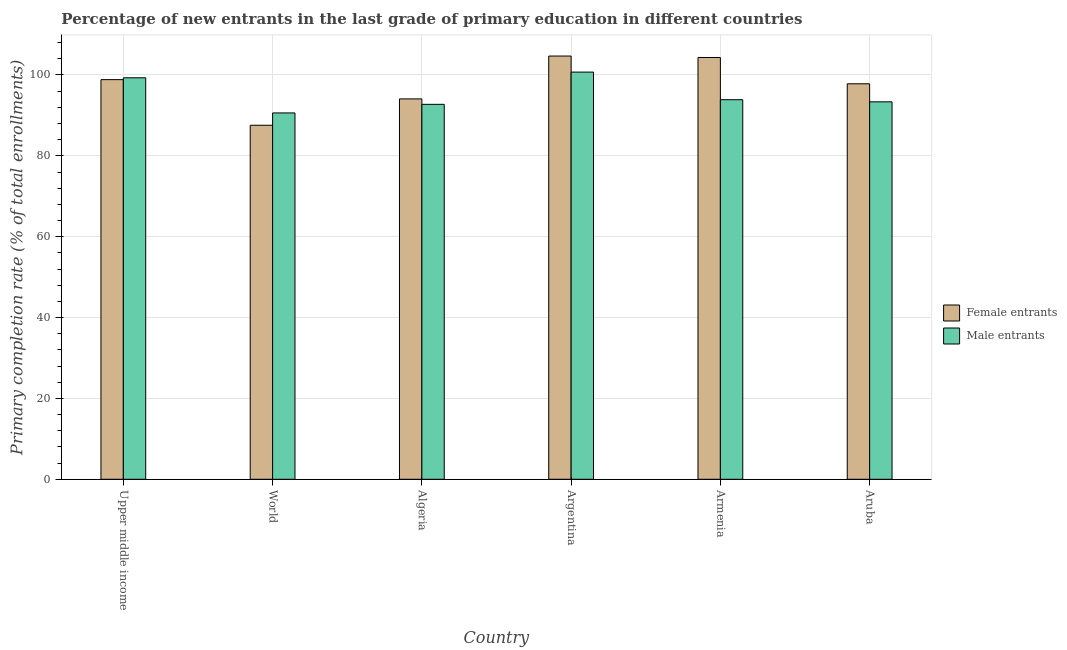How many different coloured bars are there?
Give a very brief answer. 2. How many groups of bars are there?
Give a very brief answer. 6. Are the number of bars per tick equal to the number of legend labels?
Provide a short and direct response. Yes. Are the number of bars on each tick of the X-axis equal?
Give a very brief answer. Yes. How many bars are there on the 2nd tick from the left?
Your response must be concise. 2. How many bars are there on the 3rd tick from the right?
Your answer should be very brief. 2. What is the label of the 6th group of bars from the left?
Your response must be concise. Aruba. What is the primary completion rate of male entrants in Algeria?
Provide a short and direct response. 92.74. Across all countries, what is the maximum primary completion rate of female entrants?
Offer a terse response. 104.69. Across all countries, what is the minimum primary completion rate of female entrants?
Make the answer very short. 87.57. In which country was the primary completion rate of female entrants maximum?
Make the answer very short. Argentina. In which country was the primary completion rate of male entrants minimum?
Your answer should be compact. World. What is the total primary completion rate of female entrants in the graph?
Your answer should be very brief. 587.34. What is the difference between the primary completion rate of female entrants in Argentina and that in Armenia?
Provide a short and direct response. 0.36. What is the difference between the primary completion rate of female entrants in Algeria and the primary completion rate of male entrants in Armenia?
Keep it short and to the point. 0.2. What is the average primary completion rate of male entrants per country?
Provide a succinct answer. 95.1. What is the difference between the primary completion rate of male entrants and primary completion rate of female entrants in Argentina?
Your answer should be compact. -3.97. What is the ratio of the primary completion rate of male entrants in Algeria to that in Armenia?
Offer a terse response. 0.99. Is the difference between the primary completion rate of female entrants in Armenia and Aruba greater than the difference between the primary completion rate of male entrants in Armenia and Aruba?
Your answer should be compact. Yes. What is the difference between the highest and the second highest primary completion rate of female entrants?
Your answer should be very brief. 0.36. What is the difference between the highest and the lowest primary completion rate of female entrants?
Your response must be concise. 17.12. In how many countries, is the primary completion rate of male entrants greater than the average primary completion rate of male entrants taken over all countries?
Offer a very short reply. 2. What does the 2nd bar from the left in World represents?
Your answer should be compact. Male entrants. What does the 2nd bar from the right in World represents?
Your answer should be compact. Female entrants. Are all the bars in the graph horizontal?
Your response must be concise. No. How many countries are there in the graph?
Offer a terse response. 6. What is the difference between two consecutive major ticks on the Y-axis?
Offer a terse response. 20. Where does the legend appear in the graph?
Your answer should be very brief. Center right. How are the legend labels stacked?
Keep it short and to the point. Vertical. What is the title of the graph?
Make the answer very short. Percentage of new entrants in the last grade of primary education in different countries. What is the label or title of the X-axis?
Keep it short and to the point. Country. What is the label or title of the Y-axis?
Offer a terse response. Primary completion rate (% of total enrollments). What is the Primary completion rate (% of total enrollments) in Female entrants in Upper middle income?
Give a very brief answer. 98.85. What is the Primary completion rate (% of total enrollments) of Male entrants in Upper middle income?
Your response must be concise. 99.31. What is the Primary completion rate (% of total enrollments) of Female entrants in World?
Offer a very short reply. 87.57. What is the Primary completion rate (% of total enrollments) in Male entrants in World?
Your answer should be very brief. 90.61. What is the Primary completion rate (% of total enrollments) in Female entrants in Algeria?
Your response must be concise. 94.09. What is the Primary completion rate (% of total enrollments) of Male entrants in Algeria?
Keep it short and to the point. 92.74. What is the Primary completion rate (% of total enrollments) in Female entrants in Argentina?
Your answer should be very brief. 104.69. What is the Primary completion rate (% of total enrollments) of Male entrants in Argentina?
Your response must be concise. 100.72. What is the Primary completion rate (% of total enrollments) of Female entrants in Armenia?
Offer a very short reply. 104.33. What is the Primary completion rate (% of total enrollments) of Male entrants in Armenia?
Offer a terse response. 93.88. What is the Primary completion rate (% of total enrollments) of Female entrants in Aruba?
Give a very brief answer. 97.82. What is the Primary completion rate (% of total enrollments) in Male entrants in Aruba?
Offer a terse response. 93.36. Across all countries, what is the maximum Primary completion rate (% of total enrollments) of Female entrants?
Your answer should be very brief. 104.69. Across all countries, what is the maximum Primary completion rate (% of total enrollments) of Male entrants?
Provide a succinct answer. 100.72. Across all countries, what is the minimum Primary completion rate (% of total enrollments) in Female entrants?
Provide a short and direct response. 87.57. Across all countries, what is the minimum Primary completion rate (% of total enrollments) of Male entrants?
Provide a succinct answer. 90.61. What is the total Primary completion rate (% of total enrollments) of Female entrants in the graph?
Keep it short and to the point. 587.34. What is the total Primary completion rate (% of total enrollments) of Male entrants in the graph?
Your answer should be compact. 570.63. What is the difference between the Primary completion rate (% of total enrollments) in Female entrants in Upper middle income and that in World?
Your answer should be very brief. 11.28. What is the difference between the Primary completion rate (% of total enrollments) of Male entrants in Upper middle income and that in World?
Offer a very short reply. 8.69. What is the difference between the Primary completion rate (% of total enrollments) in Female entrants in Upper middle income and that in Algeria?
Provide a short and direct response. 4.77. What is the difference between the Primary completion rate (% of total enrollments) in Male entrants in Upper middle income and that in Algeria?
Your answer should be compact. 6.57. What is the difference between the Primary completion rate (% of total enrollments) of Female entrants in Upper middle income and that in Argentina?
Offer a very short reply. -5.84. What is the difference between the Primary completion rate (% of total enrollments) of Male entrants in Upper middle income and that in Argentina?
Offer a terse response. -1.41. What is the difference between the Primary completion rate (% of total enrollments) of Female entrants in Upper middle income and that in Armenia?
Provide a succinct answer. -5.47. What is the difference between the Primary completion rate (% of total enrollments) in Male entrants in Upper middle income and that in Armenia?
Give a very brief answer. 5.43. What is the difference between the Primary completion rate (% of total enrollments) in Female entrants in Upper middle income and that in Aruba?
Your answer should be very brief. 1.03. What is the difference between the Primary completion rate (% of total enrollments) in Male entrants in Upper middle income and that in Aruba?
Keep it short and to the point. 5.95. What is the difference between the Primary completion rate (% of total enrollments) of Female entrants in World and that in Algeria?
Make the answer very short. -6.52. What is the difference between the Primary completion rate (% of total enrollments) in Male entrants in World and that in Algeria?
Keep it short and to the point. -2.13. What is the difference between the Primary completion rate (% of total enrollments) of Female entrants in World and that in Argentina?
Your response must be concise. -17.12. What is the difference between the Primary completion rate (% of total enrollments) of Male entrants in World and that in Argentina?
Make the answer very short. -10.1. What is the difference between the Primary completion rate (% of total enrollments) of Female entrants in World and that in Armenia?
Keep it short and to the point. -16.76. What is the difference between the Primary completion rate (% of total enrollments) of Male entrants in World and that in Armenia?
Your response must be concise. -3.27. What is the difference between the Primary completion rate (% of total enrollments) of Female entrants in World and that in Aruba?
Your answer should be very brief. -10.26. What is the difference between the Primary completion rate (% of total enrollments) of Male entrants in World and that in Aruba?
Your answer should be compact. -2.74. What is the difference between the Primary completion rate (% of total enrollments) in Female entrants in Algeria and that in Argentina?
Provide a succinct answer. -10.6. What is the difference between the Primary completion rate (% of total enrollments) in Male entrants in Algeria and that in Argentina?
Provide a short and direct response. -7.97. What is the difference between the Primary completion rate (% of total enrollments) in Female entrants in Algeria and that in Armenia?
Your answer should be compact. -10.24. What is the difference between the Primary completion rate (% of total enrollments) of Male entrants in Algeria and that in Armenia?
Offer a very short reply. -1.14. What is the difference between the Primary completion rate (% of total enrollments) in Female entrants in Algeria and that in Aruba?
Provide a succinct answer. -3.74. What is the difference between the Primary completion rate (% of total enrollments) in Male entrants in Algeria and that in Aruba?
Offer a terse response. -0.62. What is the difference between the Primary completion rate (% of total enrollments) of Female entrants in Argentina and that in Armenia?
Offer a very short reply. 0.36. What is the difference between the Primary completion rate (% of total enrollments) in Male entrants in Argentina and that in Armenia?
Ensure brevity in your answer.  6.83. What is the difference between the Primary completion rate (% of total enrollments) of Female entrants in Argentina and that in Aruba?
Your response must be concise. 6.87. What is the difference between the Primary completion rate (% of total enrollments) of Male entrants in Argentina and that in Aruba?
Ensure brevity in your answer.  7.36. What is the difference between the Primary completion rate (% of total enrollments) in Female entrants in Armenia and that in Aruba?
Make the answer very short. 6.5. What is the difference between the Primary completion rate (% of total enrollments) of Male entrants in Armenia and that in Aruba?
Your response must be concise. 0.53. What is the difference between the Primary completion rate (% of total enrollments) in Female entrants in Upper middle income and the Primary completion rate (% of total enrollments) in Male entrants in World?
Offer a terse response. 8.24. What is the difference between the Primary completion rate (% of total enrollments) in Female entrants in Upper middle income and the Primary completion rate (% of total enrollments) in Male entrants in Algeria?
Your response must be concise. 6.11. What is the difference between the Primary completion rate (% of total enrollments) in Female entrants in Upper middle income and the Primary completion rate (% of total enrollments) in Male entrants in Argentina?
Ensure brevity in your answer.  -1.87. What is the difference between the Primary completion rate (% of total enrollments) of Female entrants in Upper middle income and the Primary completion rate (% of total enrollments) of Male entrants in Armenia?
Your response must be concise. 4.97. What is the difference between the Primary completion rate (% of total enrollments) of Female entrants in Upper middle income and the Primary completion rate (% of total enrollments) of Male entrants in Aruba?
Give a very brief answer. 5.49. What is the difference between the Primary completion rate (% of total enrollments) of Female entrants in World and the Primary completion rate (% of total enrollments) of Male entrants in Algeria?
Give a very brief answer. -5.18. What is the difference between the Primary completion rate (% of total enrollments) of Female entrants in World and the Primary completion rate (% of total enrollments) of Male entrants in Argentina?
Offer a very short reply. -13.15. What is the difference between the Primary completion rate (% of total enrollments) in Female entrants in World and the Primary completion rate (% of total enrollments) in Male entrants in Armenia?
Provide a short and direct response. -6.32. What is the difference between the Primary completion rate (% of total enrollments) of Female entrants in World and the Primary completion rate (% of total enrollments) of Male entrants in Aruba?
Provide a short and direct response. -5.79. What is the difference between the Primary completion rate (% of total enrollments) in Female entrants in Algeria and the Primary completion rate (% of total enrollments) in Male entrants in Argentina?
Provide a short and direct response. -6.63. What is the difference between the Primary completion rate (% of total enrollments) in Female entrants in Algeria and the Primary completion rate (% of total enrollments) in Male entrants in Armenia?
Provide a succinct answer. 0.2. What is the difference between the Primary completion rate (% of total enrollments) of Female entrants in Algeria and the Primary completion rate (% of total enrollments) of Male entrants in Aruba?
Offer a terse response. 0.73. What is the difference between the Primary completion rate (% of total enrollments) in Female entrants in Argentina and the Primary completion rate (% of total enrollments) in Male entrants in Armenia?
Keep it short and to the point. 10.8. What is the difference between the Primary completion rate (% of total enrollments) in Female entrants in Argentina and the Primary completion rate (% of total enrollments) in Male entrants in Aruba?
Make the answer very short. 11.33. What is the difference between the Primary completion rate (% of total enrollments) in Female entrants in Armenia and the Primary completion rate (% of total enrollments) in Male entrants in Aruba?
Provide a succinct answer. 10.97. What is the average Primary completion rate (% of total enrollments) of Female entrants per country?
Offer a terse response. 97.89. What is the average Primary completion rate (% of total enrollments) of Male entrants per country?
Your response must be concise. 95.1. What is the difference between the Primary completion rate (% of total enrollments) of Female entrants and Primary completion rate (% of total enrollments) of Male entrants in Upper middle income?
Your answer should be compact. -0.46. What is the difference between the Primary completion rate (% of total enrollments) in Female entrants and Primary completion rate (% of total enrollments) in Male entrants in World?
Give a very brief answer. -3.05. What is the difference between the Primary completion rate (% of total enrollments) of Female entrants and Primary completion rate (% of total enrollments) of Male entrants in Algeria?
Provide a succinct answer. 1.34. What is the difference between the Primary completion rate (% of total enrollments) in Female entrants and Primary completion rate (% of total enrollments) in Male entrants in Argentina?
Ensure brevity in your answer.  3.97. What is the difference between the Primary completion rate (% of total enrollments) in Female entrants and Primary completion rate (% of total enrollments) in Male entrants in Armenia?
Provide a succinct answer. 10.44. What is the difference between the Primary completion rate (% of total enrollments) in Female entrants and Primary completion rate (% of total enrollments) in Male entrants in Aruba?
Your answer should be very brief. 4.46. What is the ratio of the Primary completion rate (% of total enrollments) in Female entrants in Upper middle income to that in World?
Your response must be concise. 1.13. What is the ratio of the Primary completion rate (% of total enrollments) in Male entrants in Upper middle income to that in World?
Keep it short and to the point. 1.1. What is the ratio of the Primary completion rate (% of total enrollments) in Female entrants in Upper middle income to that in Algeria?
Make the answer very short. 1.05. What is the ratio of the Primary completion rate (% of total enrollments) of Male entrants in Upper middle income to that in Algeria?
Your answer should be very brief. 1.07. What is the ratio of the Primary completion rate (% of total enrollments) of Female entrants in Upper middle income to that in Argentina?
Ensure brevity in your answer.  0.94. What is the ratio of the Primary completion rate (% of total enrollments) in Female entrants in Upper middle income to that in Armenia?
Provide a short and direct response. 0.95. What is the ratio of the Primary completion rate (% of total enrollments) in Male entrants in Upper middle income to that in Armenia?
Make the answer very short. 1.06. What is the ratio of the Primary completion rate (% of total enrollments) in Female entrants in Upper middle income to that in Aruba?
Ensure brevity in your answer.  1.01. What is the ratio of the Primary completion rate (% of total enrollments) of Male entrants in Upper middle income to that in Aruba?
Your answer should be very brief. 1.06. What is the ratio of the Primary completion rate (% of total enrollments) in Female entrants in World to that in Algeria?
Keep it short and to the point. 0.93. What is the ratio of the Primary completion rate (% of total enrollments) of Male entrants in World to that in Algeria?
Provide a short and direct response. 0.98. What is the ratio of the Primary completion rate (% of total enrollments) in Female entrants in World to that in Argentina?
Provide a short and direct response. 0.84. What is the ratio of the Primary completion rate (% of total enrollments) in Male entrants in World to that in Argentina?
Provide a short and direct response. 0.9. What is the ratio of the Primary completion rate (% of total enrollments) in Female entrants in World to that in Armenia?
Offer a very short reply. 0.84. What is the ratio of the Primary completion rate (% of total enrollments) in Male entrants in World to that in Armenia?
Keep it short and to the point. 0.97. What is the ratio of the Primary completion rate (% of total enrollments) of Female entrants in World to that in Aruba?
Your response must be concise. 0.9. What is the ratio of the Primary completion rate (% of total enrollments) of Male entrants in World to that in Aruba?
Offer a very short reply. 0.97. What is the ratio of the Primary completion rate (% of total enrollments) in Female entrants in Algeria to that in Argentina?
Offer a very short reply. 0.9. What is the ratio of the Primary completion rate (% of total enrollments) in Male entrants in Algeria to that in Argentina?
Provide a short and direct response. 0.92. What is the ratio of the Primary completion rate (% of total enrollments) in Female entrants in Algeria to that in Armenia?
Give a very brief answer. 0.9. What is the ratio of the Primary completion rate (% of total enrollments) in Male entrants in Algeria to that in Armenia?
Keep it short and to the point. 0.99. What is the ratio of the Primary completion rate (% of total enrollments) in Female entrants in Algeria to that in Aruba?
Your answer should be compact. 0.96. What is the ratio of the Primary completion rate (% of total enrollments) of Male entrants in Argentina to that in Armenia?
Offer a terse response. 1.07. What is the ratio of the Primary completion rate (% of total enrollments) of Female entrants in Argentina to that in Aruba?
Ensure brevity in your answer.  1.07. What is the ratio of the Primary completion rate (% of total enrollments) in Male entrants in Argentina to that in Aruba?
Give a very brief answer. 1.08. What is the ratio of the Primary completion rate (% of total enrollments) of Female entrants in Armenia to that in Aruba?
Provide a succinct answer. 1.07. What is the ratio of the Primary completion rate (% of total enrollments) in Male entrants in Armenia to that in Aruba?
Your response must be concise. 1.01. What is the difference between the highest and the second highest Primary completion rate (% of total enrollments) in Female entrants?
Keep it short and to the point. 0.36. What is the difference between the highest and the second highest Primary completion rate (% of total enrollments) of Male entrants?
Offer a very short reply. 1.41. What is the difference between the highest and the lowest Primary completion rate (% of total enrollments) in Female entrants?
Provide a short and direct response. 17.12. What is the difference between the highest and the lowest Primary completion rate (% of total enrollments) of Male entrants?
Make the answer very short. 10.1. 